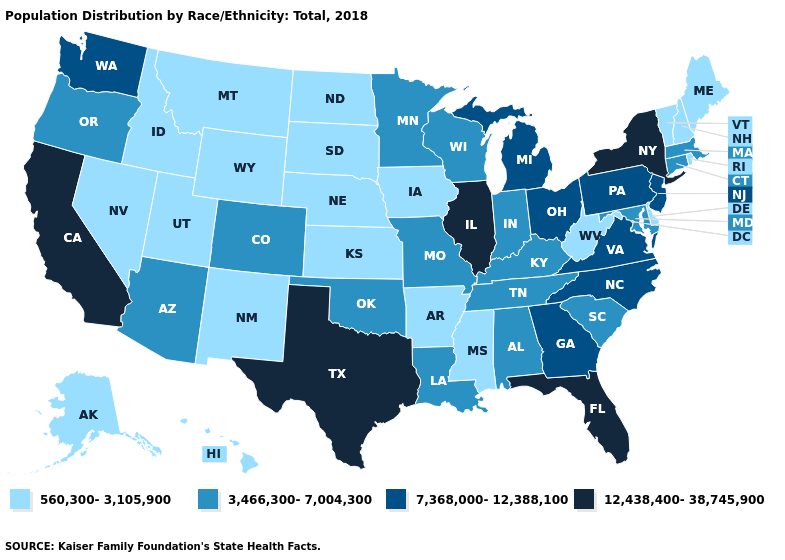Name the states that have a value in the range 7,368,000-12,388,100?
Give a very brief answer. Georgia, Michigan, New Jersey, North Carolina, Ohio, Pennsylvania, Virginia, Washington. Name the states that have a value in the range 7,368,000-12,388,100?
Quick response, please. Georgia, Michigan, New Jersey, North Carolina, Ohio, Pennsylvania, Virginia, Washington. Which states have the highest value in the USA?
Write a very short answer. California, Florida, Illinois, New York, Texas. What is the lowest value in the USA?
Write a very short answer. 560,300-3,105,900. What is the value of Arkansas?
Be succinct. 560,300-3,105,900. Name the states that have a value in the range 12,438,400-38,745,900?
Write a very short answer. California, Florida, Illinois, New York, Texas. Name the states that have a value in the range 12,438,400-38,745,900?
Short answer required. California, Florida, Illinois, New York, Texas. Does North Dakota have the lowest value in the USA?
Concise answer only. Yes. What is the value of Nevada?
Short answer required. 560,300-3,105,900. What is the value of Oregon?
Be succinct. 3,466,300-7,004,300. What is the value of South Dakota?
Short answer required. 560,300-3,105,900. Does Tennessee have the highest value in the USA?
Concise answer only. No. Does California have the lowest value in the USA?
Quick response, please. No. Does Wyoming have the lowest value in the USA?
Short answer required. Yes. What is the lowest value in states that border Idaho?
Write a very short answer. 560,300-3,105,900. 